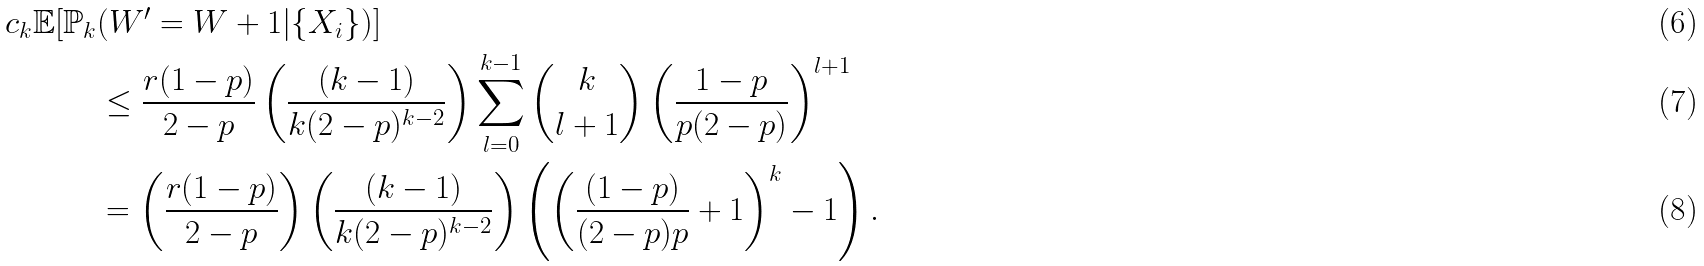<formula> <loc_0><loc_0><loc_500><loc_500>c _ { k } \mathbb { E } [ \mathbb { P } _ { k } & ( W ^ { \prime } = W + 1 | \{ X _ { i } \} ) ] \\ & \leq \frac { r ( 1 - p ) } { 2 - p } \left ( \frac { ( k - 1 ) } { k ( 2 - p ) ^ { k - 2 } } \right ) \sum _ { l = 0 } ^ { k - 1 } \binom { k } { l + 1 } \left ( \frac { 1 - p } { p ( 2 - p ) } \right ) ^ { l + 1 } \\ & = \left ( \frac { r ( 1 - p ) } { 2 - p } \right ) \left ( \frac { ( k - 1 ) } { k ( 2 - p ) ^ { k - 2 } } \right ) \left ( \left ( \frac { ( 1 - p ) } { ( 2 - p ) p } + 1 \right ) ^ { k } - 1 \right ) .</formula> 